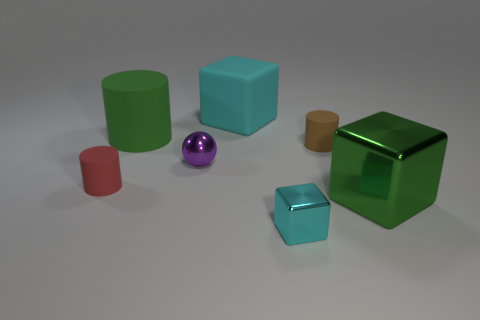Is there a small cyan shiny thing in front of the large green thing behind the small rubber object that is on the left side of the large matte cylinder?
Make the answer very short. Yes. The cyan thing that is the same size as the green rubber cylinder is what shape?
Provide a short and direct response. Cube. Are there any big cylinders that have the same color as the big shiny thing?
Give a very brief answer. Yes. Do the green metal object and the purple object have the same shape?
Keep it short and to the point. No. How many big things are green blocks or cyan matte things?
Make the answer very short. 2. The other block that is made of the same material as the green block is what color?
Ensure brevity in your answer.  Cyan. How many tiny cyan things are made of the same material as the small purple ball?
Make the answer very short. 1. There is a metal block left of the big green metal object; is its size the same as the block behind the large green metal thing?
Give a very brief answer. No. What is the material of the cyan thing in front of the green object behind the red cylinder?
Your answer should be compact. Metal. Are there fewer tiny cyan metal objects to the left of the tiny red matte thing than cyan things that are behind the green rubber thing?
Make the answer very short. Yes. 